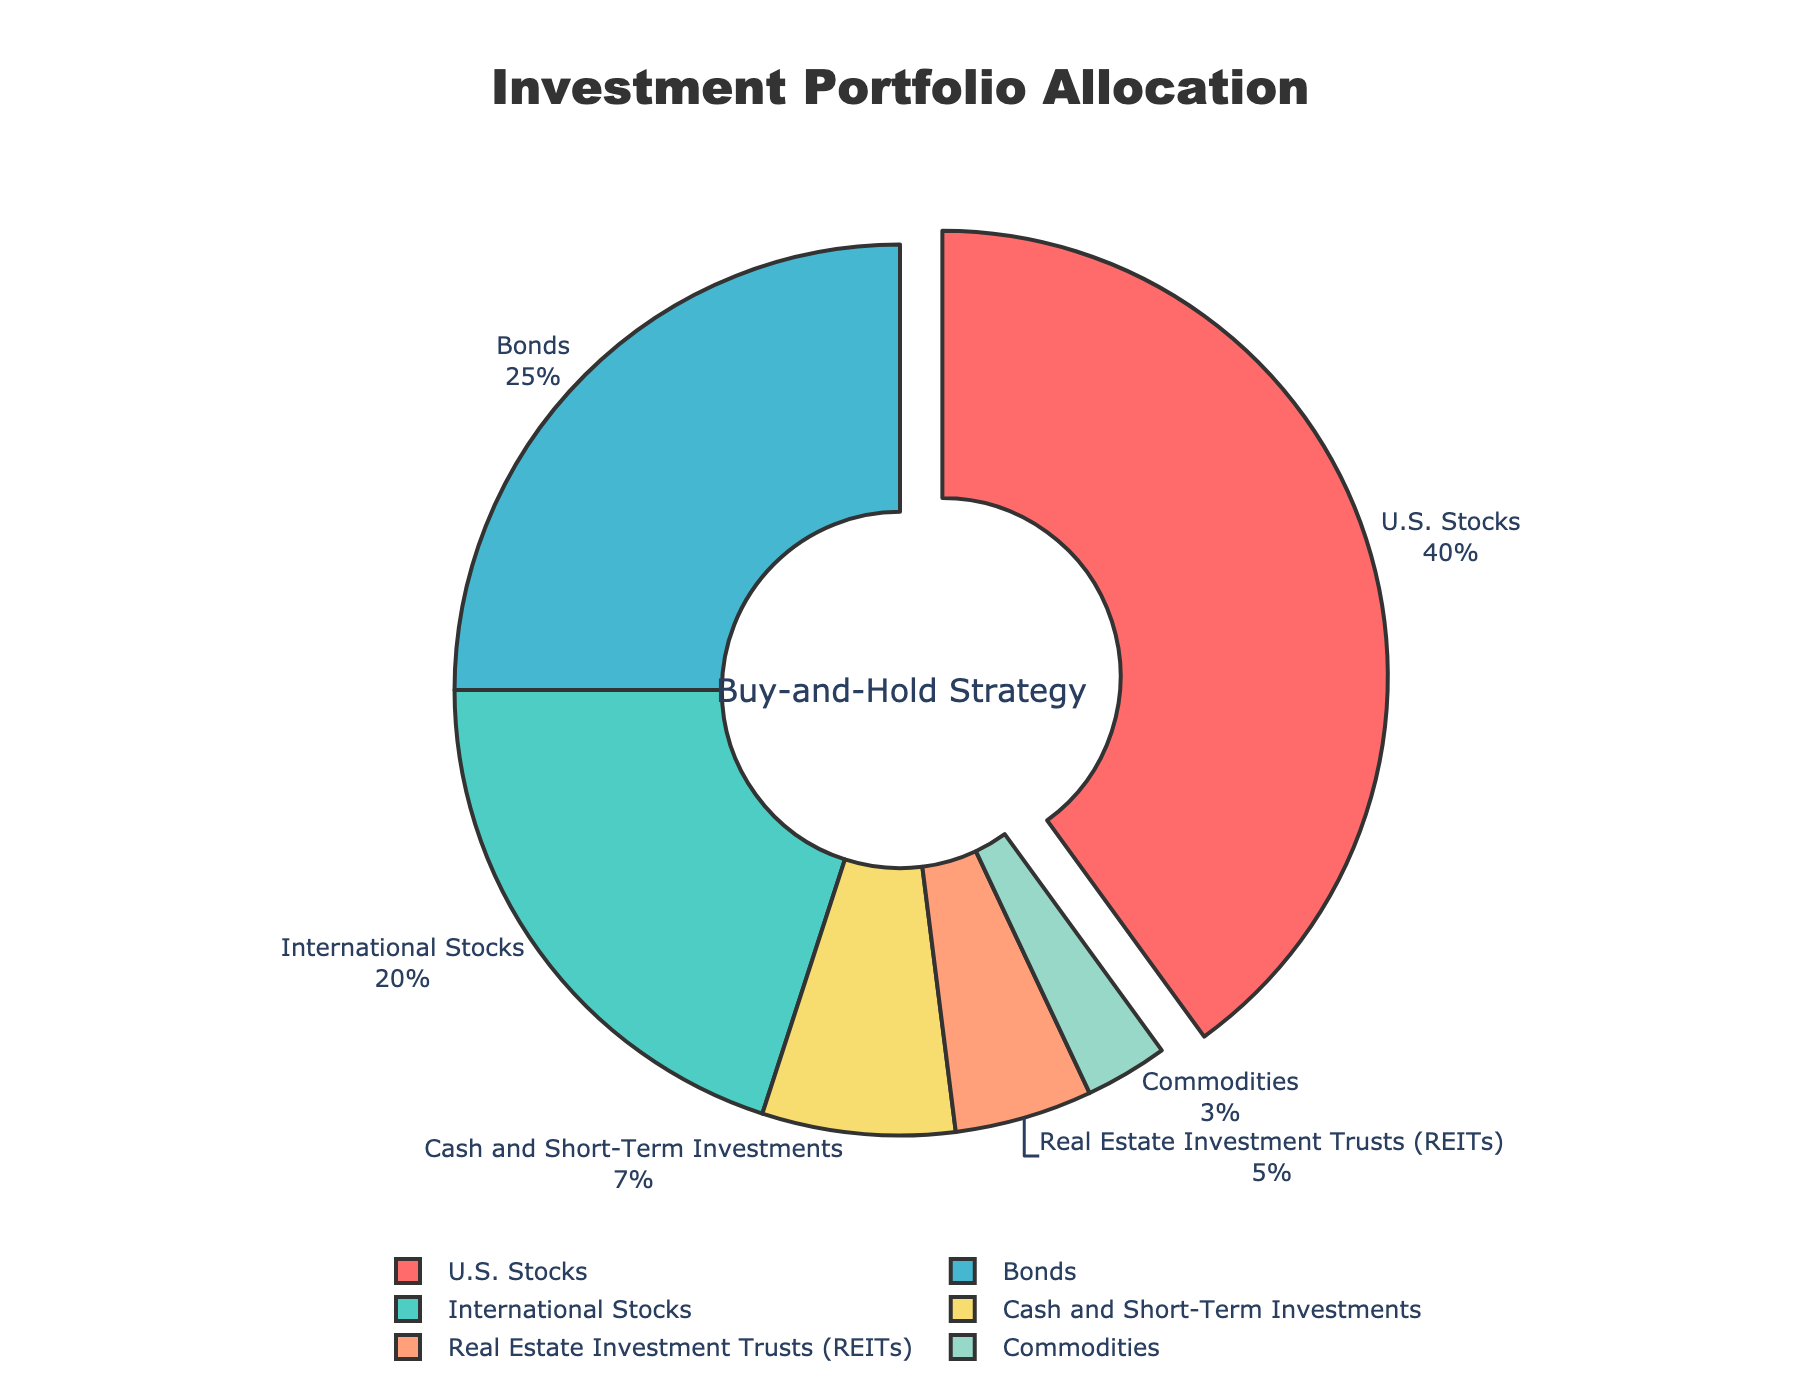Which asset classes constitute 65% of the portfolio? According to the pie chart, U.S. Stocks constitute 40% and Bonds constitute 25% of the portfolio. Adding these gives 40% + 25% = 65%.
Answer: U.S. Stocks and Bonds Which asset class occupies the largest portion of the portfolio? The segment that is pulled out slightly and has the largest percentage label is U.S. Stocks with 40%.
Answer: U.S. Stocks How much higher is the allocation to U.S. Stocks compared to International Stocks? The allocation to U.S. Stocks is 40%, and to International Stocks is 20%. The difference is 40% - 20% = 20%.
Answer: 20% What is the combined percentage of Commodities and Cash & Short-Term Investments? The allocation to Commodities is 3% and to Cash & Short-Term Investments is 7%. Their combined percentage is 3% + 7% = 10%.
Answer: 10% How does the percentage allocation to Bonds compare to that of Real Estate Investment Trusts (REITs)? The allocation to Bonds is 25%, while the allocation to REITs is 5%. Thus, Bonds have a higher allocation by 25% - 5% = 20%.
Answer: Bonds are higher by 20% What is the average allocation percentage of the asset classes? Summing all the percentages, we get 40% + 20% + 25% + 5% + 3% + 7% = 100%. There are 6 asset classes, so the average is 100% / 6 ≈ 16.67%.
Answer: 16.67% Which asset class is represented by a green color? The pie chart shows International Stocks in green.
Answer: International Stocks What share does Real Estate Investment Trusts (REITs) hold in the overall portfolio? The pie chart indicates that Real Estate Investment Trusts (REITs) constitute 5% of the portfolio.
Answer: 5% Which asset classes combined have a higher allocation than U.S. Stocks? The combined allocation of International Stocks, Bonds, REITs, Commodities, and Cash & Short-Term Investments is 20% + 25% + 5% + 3% + 7% = 60%, which is higher than U.S. Stocks' 40%.
Answer: International Stocks, Bonds, REITs, Commodities, Cash & Short-Term Investments What percentage of the portfolio is allocated to asset classes other than U.S. Stocks and Bonds? The combined percentage of the other asset classes is International Stocks 20%, REITs 5%, Commodities 3%, and Cash & Short-Term Investments 7%, which sum up to 20% + 5% + 3% + 7% = 35%.
Answer: 35% 